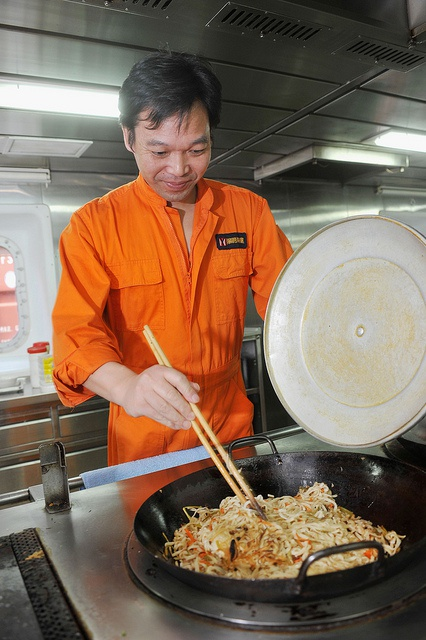Describe the objects in this image and their specific colors. I can see people in gray, red, brown, tan, and black tones in this image. 